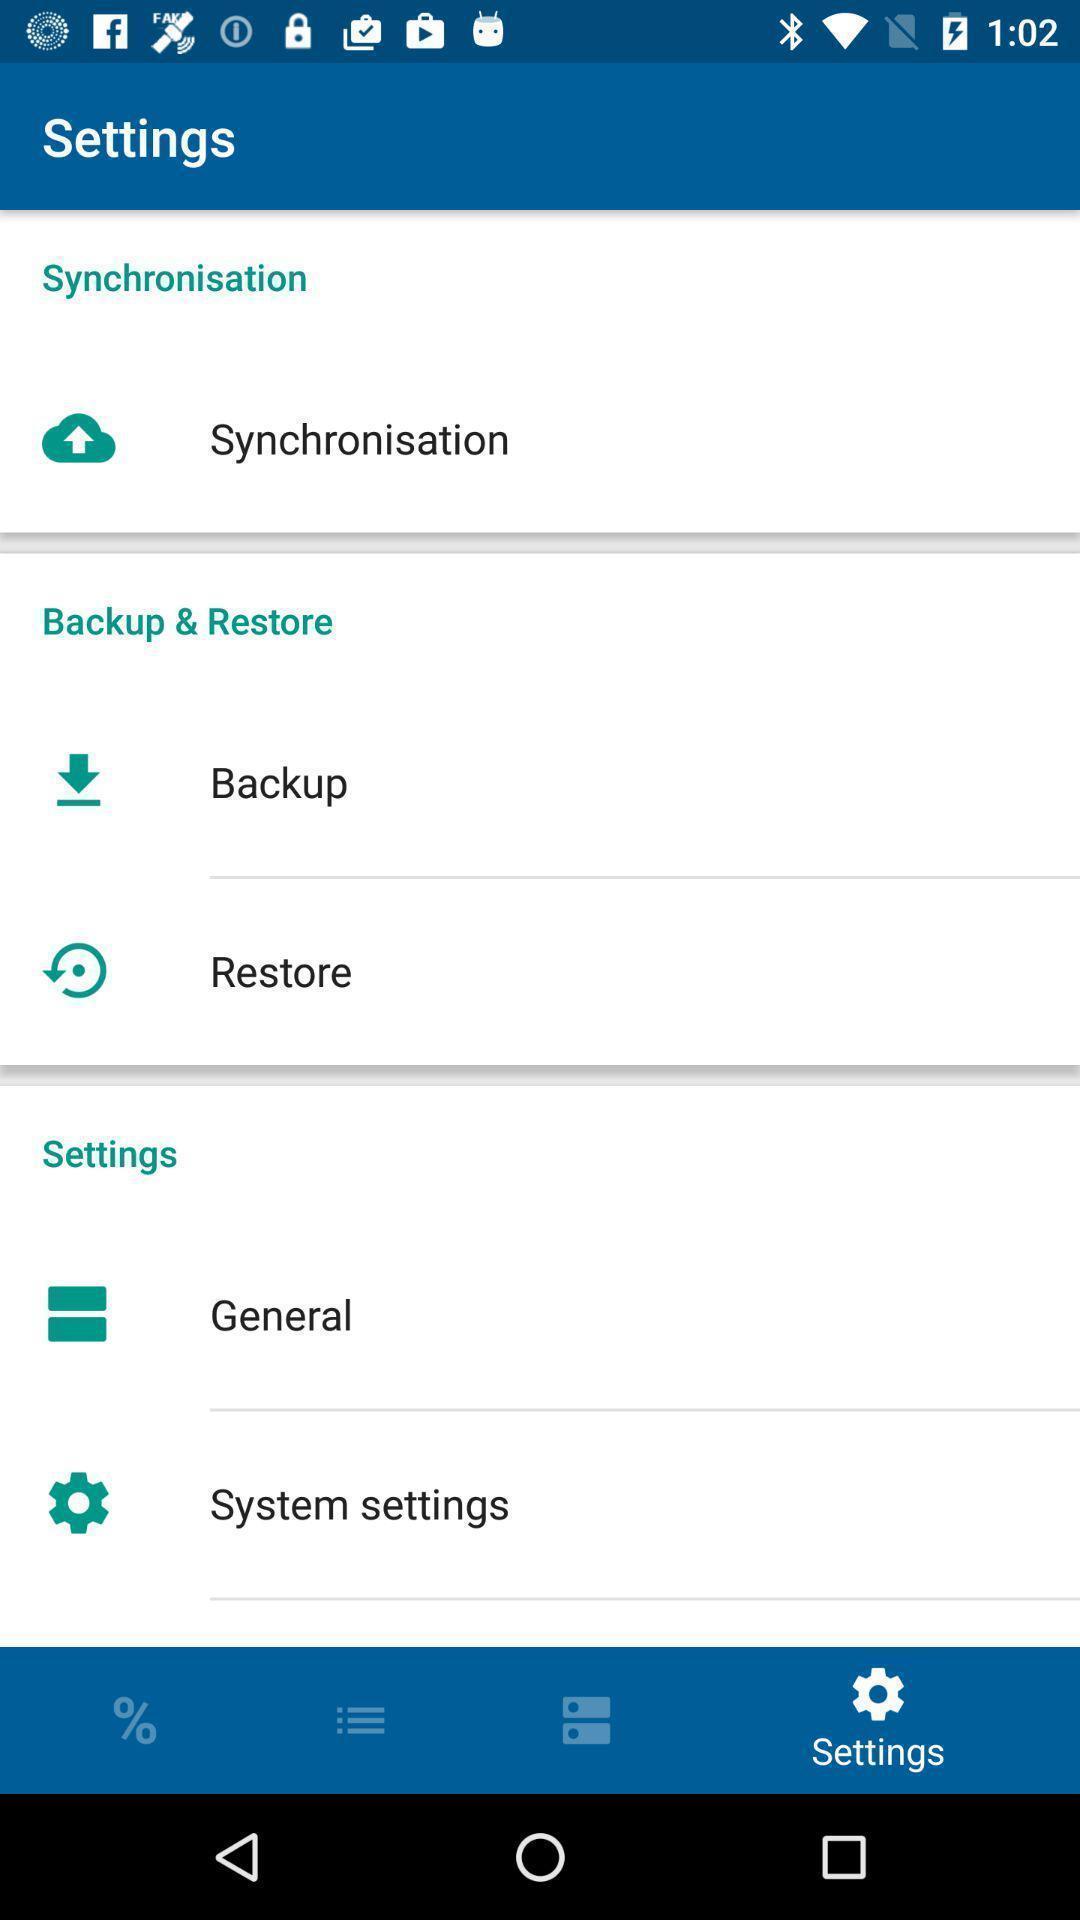Provide a detailed account of this screenshot. Social app showing list of settings. 